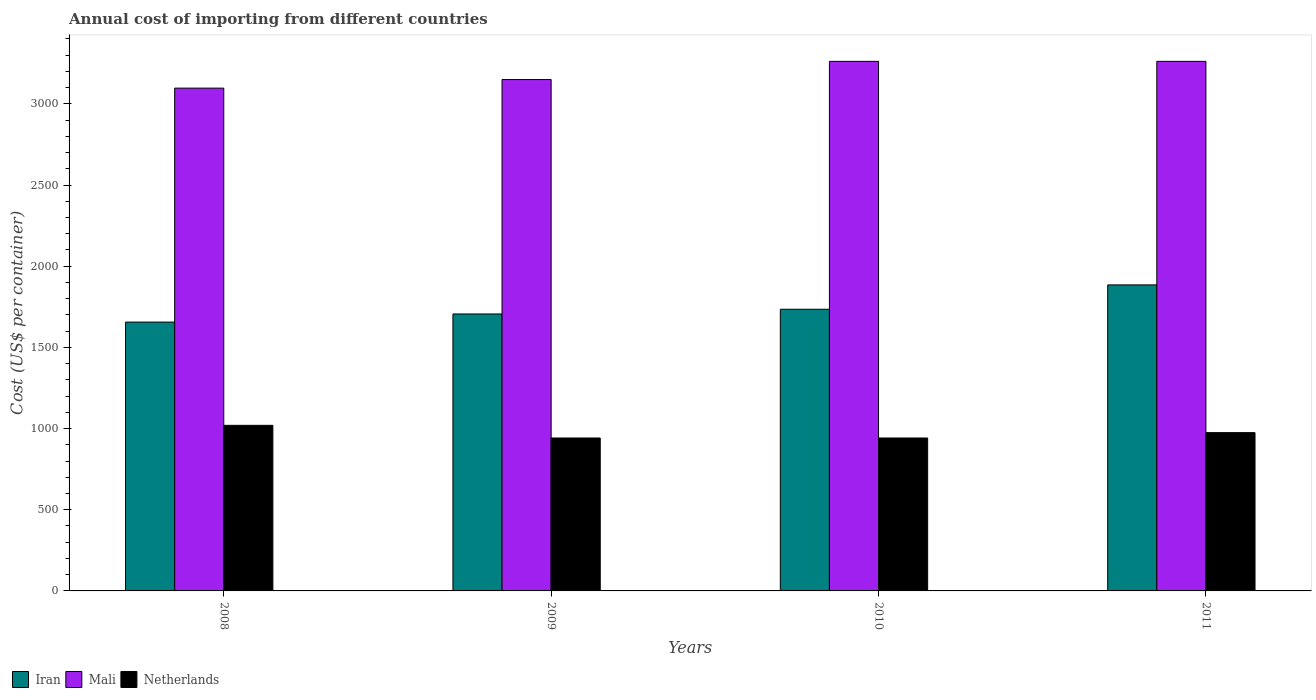Are the number of bars per tick equal to the number of legend labels?
Provide a short and direct response. Yes. Are the number of bars on each tick of the X-axis equal?
Offer a terse response. Yes. What is the label of the 1st group of bars from the left?
Provide a short and direct response. 2008. What is the total annual cost of importing in Netherlands in 2009?
Make the answer very short. 942. Across all years, what is the maximum total annual cost of importing in Mali?
Offer a terse response. 3262. Across all years, what is the minimum total annual cost of importing in Iran?
Keep it short and to the point. 1656. What is the total total annual cost of importing in Mali in the graph?
Offer a terse response. 1.28e+04. What is the difference between the total annual cost of importing in Mali in 2008 and that in 2009?
Offer a terse response. -53. What is the difference between the total annual cost of importing in Mali in 2008 and the total annual cost of importing in Netherlands in 2010?
Your answer should be compact. 2155. What is the average total annual cost of importing in Netherlands per year?
Make the answer very short. 969.75. In the year 2009, what is the difference between the total annual cost of importing in Netherlands and total annual cost of importing in Mali?
Offer a very short reply. -2208. What is the ratio of the total annual cost of importing in Netherlands in 2009 to that in 2011?
Provide a short and direct response. 0.97. Is the difference between the total annual cost of importing in Netherlands in 2010 and 2011 greater than the difference between the total annual cost of importing in Mali in 2010 and 2011?
Make the answer very short. No. What is the difference between the highest and the second highest total annual cost of importing in Mali?
Keep it short and to the point. 0. What is the difference between the highest and the lowest total annual cost of importing in Mali?
Keep it short and to the point. 165. In how many years, is the total annual cost of importing in Mali greater than the average total annual cost of importing in Mali taken over all years?
Offer a very short reply. 2. What does the 2nd bar from the left in 2011 represents?
Your answer should be very brief. Mali. What does the 2nd bar from the right in 2008 represents?
Offer a very short reply. Mali. How many bars are there?
Offer a very short reply. 12. Are all the bars in the graph horizontal?
Offer a terse response. No. How many years are there in the graph?
Your answer should be compact. 4. Does the graph contain any zero values?
Offer a terse response. No. Where does the legend appear in the graph?
Your response must be concise. Bottom left. What is the title of the graph?
Make the answer very short. Annual cost of importing from different countries. What is the label or title of the Y-axis?
Provide a succinct answer. Cost (US$ per container). What is the Cost (US$ per container) of Iran in 2008?
Provide a succinct answer. 1656. What is the Cost (US$ per container) of Mali in 2008?
Offer a very short reply. 3097. What is the Cost (US$ per container) of Netherlands in 2008?
Your response must be concise. 1020. What is the Cost (US$ per container) in Iran in 2009?
Provide a succinct answer. 1706. What is the Cost (US$ per container) of Mali in 2009?
Make the answer very short. 3150. What is the Cost (US$ per container) in Netherlands in 2009?
Ensure brevity in your answer.  942. What is the Cost (US$ per container) of Iran in 2010?
Keep it short and to the point. 1735. What is the Cost (US$ per container) in Mali in 2010?
Ensure brevity in your answer.  3262. What is the Cost (US$ per container) of Netherlands in 2010?
Provide a succinct answer. 942. What is the Cost (US$ per container) in Iran in 2011?
Ensure brevity in your answer.  1885. What is the Cost (US$ per container) of Mali in 2011?
Your response must be concise. 3262. What is the Cost (US$ per container) in Netherlands in 2011?
Provide a succinct answer. 975. Across all years, what is the maximum Cost (US$ per container) in Iran?
Keep it short and to the point. 1885. Across all years, what is the maximum Cost (US$ per container) in Mali?
Your answer should be very brief. 3262. Across all years, what is the maximum Cost (US$ per container) in Netherlands?
Keep it short and to the point. 1020. Across all years, what is the minimum Cost (US$ per container) of Iran?
Give a very brief answer. 1656. Across all years, what is the minimum Cost (US$ per container) in Mali?
Provide a short and direct response. 3097. Across all years, what is the minimum Cost (US$ per container) in Netherlands?
Provide a short and direct response. 942. What is the total Cost (US$ per container) of Iran in the graph?
Give a very brief answer. 6982. What is the total Cost (US$ per container) in Mali in the graph?
Make the answer very short. 1.28e+04. What is the total Cost (US$ per container) in Netherlands in the graph?
Offer a very short reply. 3879. What is the difference between the Cost (US$ per container) of Iran in 2008 and that in 2009?
Offer a very short reply. -50. What is the difference between the Cost (US$ per container) in Mali in 2008 and that in 2009?
Offer a very short reply. -53. What is the difference between the Cost (US$ per container) in Netherlands in 2008 and that in 2009?
Provide a short and direct response. 78. What is the difference between the Cost (US$ per container) of Iran in 2008 and that in 2010?
Offer a very short reply. -79. What is the difference between the Cost (US$ per container) of Mali in 2008 and that in 2010?
Your answer should be compact. -165. What is the difference between the Cost (US$ per container) in Iran in 2008 and that in 2011?
Your answer should be very brief. -229. What is the difference between the Cost (US$ per container) in Mali in 2008 and that in 2011?
Offer a very short reply. -165. What is the difference between the Cost (US$ per container) of Netherlands in 2008 and that in 2011?
Provide a short and direct response. 45. What is the difference between the Cost (US$ per container) in Mali in 2009 and that in 2010?
Keep it short and to the point. -112. What is the difference between the Cost (US$ per container) in Netherlands in 2009 and that in 2010?
Provide a short and direct response. 0. What is the difference between the Cost (US$ per container) in Iran in 2009 and that in 2011?
Ensure brevity in your answer.  -179. What is the difference between the Cost (US$ per container) in Mali in 2009 and that in 2011?
Your answer should be very brief. -112. What is the difference between the Cost (US$ per container) of Netherlands in 2009 and that in 2011?
Your answer should be compact. -33. What is the difference between the Cost (US$ per container) of Iran in 2010 and that in 2011?
Ensure brevity in your answer.  -150. What is the difference between the Cost (US$ per container) in Netherlands in 2010 and that in 2011?
Your answer should be very brief. -33. What is the difference between the Cost (US$ per container) of Iran in 2008 and the Cost (US$ per container) of Mali in 2009?
Your response must be concise. -1494. What is the difference between the Cost (US$ per container) of Iran in 2008 and the Cost (US$ per container) of Netherlands in 2009?
Ensure brevity in your answer.  714. What is the difference between the Cost (US$ per container) in Mali in 2008 and the Cost (US$ per container) in Netherlands in 2009?
Make the answer very short. 2155. What is the difference between the Cost (US$ per container) in Iran in 2008 and the Cost (US$ per container) in Mali in 2010?
Make the answer very short. -1606. What is the difference between the Cost (US$ per container) of Iran in 2008 and the Cost (US$ per container) of Netherlands in 2010?
Your answer should be very brief. 714. What is the difference between the Cost (US$ per container) of Mali in 2008 and the Cost (US$ per container) of Netherlands in 2010?
Give a very brief answer. 2155. What is the difference between the Cost (US$ per container) in Iran in 2008 and the Cost (US$ per container) in Mali in 2011?
Offer a terse response. -1606. What is the difference between the Cost (US$ per container) of Iran in 2008 and the Cost (US$ per container) of Netherlands in 2011?
Keep it short and to the point. 681. What is the difference between the Cost (US$ per container) of Mali in 2008 and the Cost (US$ per container) of Netherlands in 2011?
Offer a terse response. 2122. What is the difference between the Cost (US$ per container) of Iran in 2009 and the Cost (US$ per container) of Mali in 2010?
Provide a succinct answer. -1556. What is the difference between the Cost (US$ per container) of Iran in 2009 and the Cost (US$ per container) of Netherlands in 2010?
Provide a succinct answer. 764. What is the difference between the Cost (US$ per container) of Mali in 2009 and the Cost (US$ per container) of Netherlands in 2010?
Provide a succinct answer. 2208. What is the difference between the Cost (US$ per container) in Iran in 2009 and the Cost (US$ per container) in Mali in 2011?
Offer a terse response. -1556. What is the difference between the Cost (US$ per container) of Iran in 2009 and the Cost (US$ per container) of Netherlands in 2011?
Your response must be concise. 731. What is the difference between the Cost (US$ per container) in Mali in 2009 and the Cost (US$ per container) in Netherlands in 2011?
Make the answer very short. 2175. What is the difference between the Cost (US$ per container) of Iran in 2010 and the Cost (US$ per container) of Mali in 2011?
Your answer should be very brief. -1527. What is the difference between the Cost (US$ per container) in Iran in 2010 and the Cost (US$ per container) in Netherlands in 2011?
Provide a succinct answer. 760. What is the difference between the Cost (US$ per container) in Mali in 2010 and the Cost (US$ per container) in Netherlands in 2011?
Give a very brief answer. 2287. What is the average Cost (US$ per container) of Iran per year?
Your answer should be very brief. 1745.5. What is the average Cost (US$ per container) in Mali per year?
Provide a succinct answer. 3192.75. What is the average Cost (US$ per container) of Netherlands per year?
Provide a succinct answer. 969.75. In the year 2008, what is the difference between the Cost (US$ per container) of Iran and Cost (US$ per container) of Mali?
Provide a succinct answer. -1441. In the year 2008, what is the difference between the Cost (US$ per container) in Iran and Cost (US$ per container) in Netherlands?
Provide a short and direct response. 636. In the year 2008, what is the difference between the Cost (US$ per container) in Mali and Cost (US$ per container) in Netherlands?
Your answer should be very brief. 2077. In the year 2009, what is the difference between the Cost (US$ per container) of Iran and Cost (US$ per container) of Mali?
Provide a succinct answer. -1444. In the year 2009, what is the difference between the Cost (US$ per container) of Iran and Cost (US$ per container) of Netherlands?
Ensure brevity in your answer.  764. In the year 2009, what is the difference between the Cost (US$ per container) in Mali and Cost (US$ per container) in Netherlands?
Ensure brevity in your answer.  2208. In the year 2010, what is the difference between the Cost (US$ per container) in Iran and Cost (US$ per container) in Mali?
Keep it short and to the point. -1527. In the year 2010, what is the difference between the Cost (US$ per container) of Iran and Cost (US$ per container) of Netherlands?
Offer a very short reply. 793. In the year 2010, what is the difference between the Cost (US$ per container) of Mali and Cost (US$ per container) of Netherlands?
Offer a terse response. 2320. In the year 2011, what is the difference between the Cost (US$ per container) in Iran and Cost (US$ per container) in Mali?
Your answer should be very brief. -1377. In the year 2011, what is the difference between the Cost (US$ per container) of Iran and Cost (US$ per container) of Netherlands?
Your response must be concise. 910. In the year 2011, what is the difference between the Cost (US$ per container) in Mali and Cost (US$ per container) in Netherlands?
Make the answer very short. 2287. What is the ratio of the Cost (US$ per container) of Iran in 2008 to that in 2009?
Your response must be concise. 0.97. What is the ratio of the Cost (US$ per container) in Mali in 2008 to that in 2009?
Offer a very short reply. 0.98. What is the ratio of the Cost (US$ per container) in Netherlands in 2008 to that in 2009?
Offer a very short reply. 1.08. What is the ratio of the Cost (US$ per container) in Iran in 2008 to that in 2010?
Provide a short and direct response. 0.95. What is the ratio of the Cost (US$ per container) of Mali in 2008 to that in 2010?
Ensure brevity in your answer.  0.95. What is the ratio of the Cost (US$ per container) in Netherlands in 2008 to that in 2010?
Offer a terse response. 1.08. What is the ratio of the Cost (US$ per container) in Iran in 2008 to that in 2011?
Keep it short and to the point. 0.88. What is the ratio of the Cost (US$ per container) in Mali in 2008 to that in 2011?
Make the answer very short. 0.95. What is the ratio of the Cost (US$ per container) of Netherlands in 2008 to that in 2011?
Offer a terse response. 1.05. What is the ratio of the Cost (US$ per container) of Iran in 2009 to that in 2010?
Make the answer very short. 0.98. What is the ratio of the Cost (US$ per container) in Mali in 2009 to that in 2010?
Ensure brevity in your answer.  0.97. What is the ratio of the Cost (US$ per container) in Iran in 2009 to that in 2011?
Make the answer very short. 0.91. What is the ratio of the Cost (US$ per container) of Mali in 2009 to that in 2011?
Give a very brief answer. 0.97. What is the ratio of the Cost (US$ per container) in Netherlands in 2009 to that in 2011?
Offer a very short reply. 0.97. What is the ratio of the Cost (US$ per container) of Iran in 2010 to that in 2011?
Provide a succinct answer. 0.92. What is the ratio of the Cost (US$ per container) in Netherlands in 2010 to that in 2011?
Your answer should be compact. 0.97. What is the difference between the highest and the second highest Cost (US$ per container) of Iran?
Give a very brief answer. 150. What is the difference between the highest and the second highest Cost (US$ per container) in Mali?
Ensure brevity in your answer.  0. What is the difference between the highest and the lowest Cost (US$ per container) of Iran?
Make the answer very short. 229. What is the difference between the highest and the lowest Cost (US$ per container) of Mali?
Ensure brevity in your answer.  165. What is the difference between the highest and the lowest Cost (US$ per container) of Netherlands?
Ensure brevity in your answer.  78. 